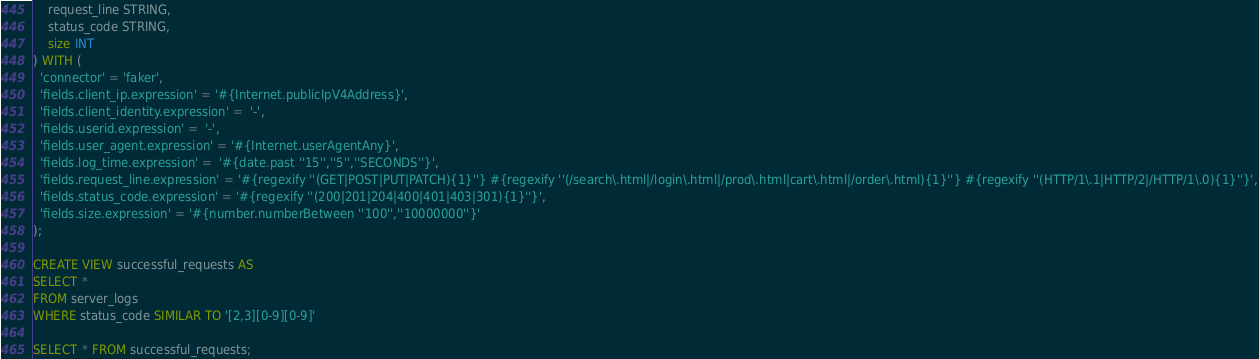Convert code to text. <code><loc_0><loc_0><loc_500><loc_500><_SQL_>    request_line STRING,
    status_code STRING,
    size INT
) WITH (
  'connector' = 'faker',
  'fields.client_ip.expression' = '#{Internet.publicIpV4Address}',
  'fields.client_identity.expression' =  '-',
  'fields.userid.expression' =  '-',
  'fields.user_agent.expression' = '#{Internet.userAgentAny}',
  'fields.log_time.expression' =  '#{date.past ''15'',''5'',''SECONDS''}',
  'fields.request_line.expression' = '#{regexify ''(GET|POST|PUT|PATCH){1}''} #{regexify ''(/search\.html|/login\.html|/prod\.html|cart\.html|/order\.html){1}''} #{regexify ''(HTTP/1\.1|HTTP/2|/HTTP/1\.0){1}''}',
  'fields.status_code.expression' = '#{regexify ''(200|201|204|400|401|403|301){1}''}',
  'fields.size.expression' = '#{number.numberBetween ''100'',''10000000''}'
);

CREATE VIEW successful_requests AS
SELECT *
FROM server_logs
WHERE status_code SIMILAR TO '[2,3][0-9][0-9]'

SELECT * FROM successful_requests;</code> 